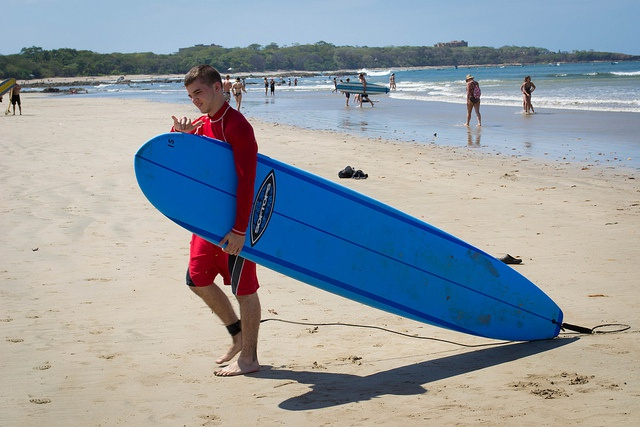Describe the objects in this image and their specific colors. I can see surfboard in lightblue, blue, navy, maroon, and darkblue tones, people in lightblue, maroon, brown, and black tones, people in lightblue, maroon, gray, black, and darkgray tones, surfboard in lightblue, blue, and gray tones, and people in lightblue, black, maroon, and gray tones in this image. 